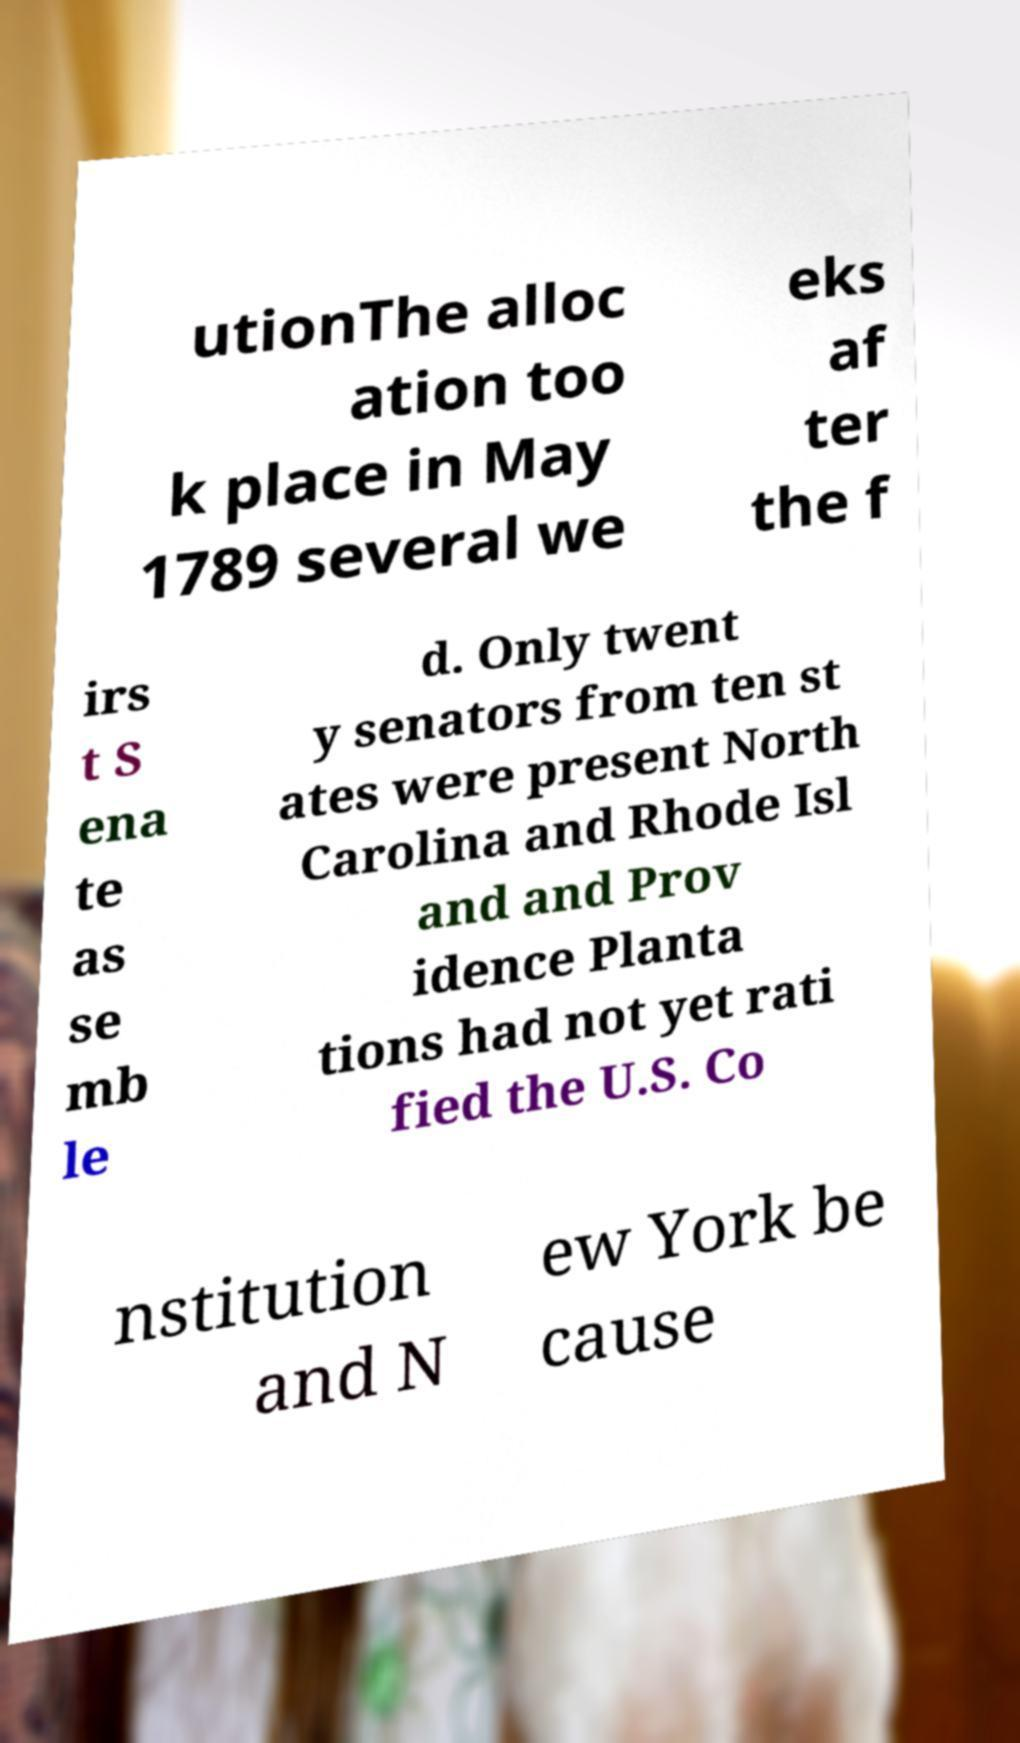I need the written content from this picture converted into text. Can you do that? utionThe alloc ation too k place in May 1789 several we eks af ter the f irs t S ena te as se mb le d. Only twent y senators from ten st ates were present North Carolina and Rhode Isl and and Prov idence Planta tions had not yet rati fied the U.S. Co nstitution and N ew York be cause 